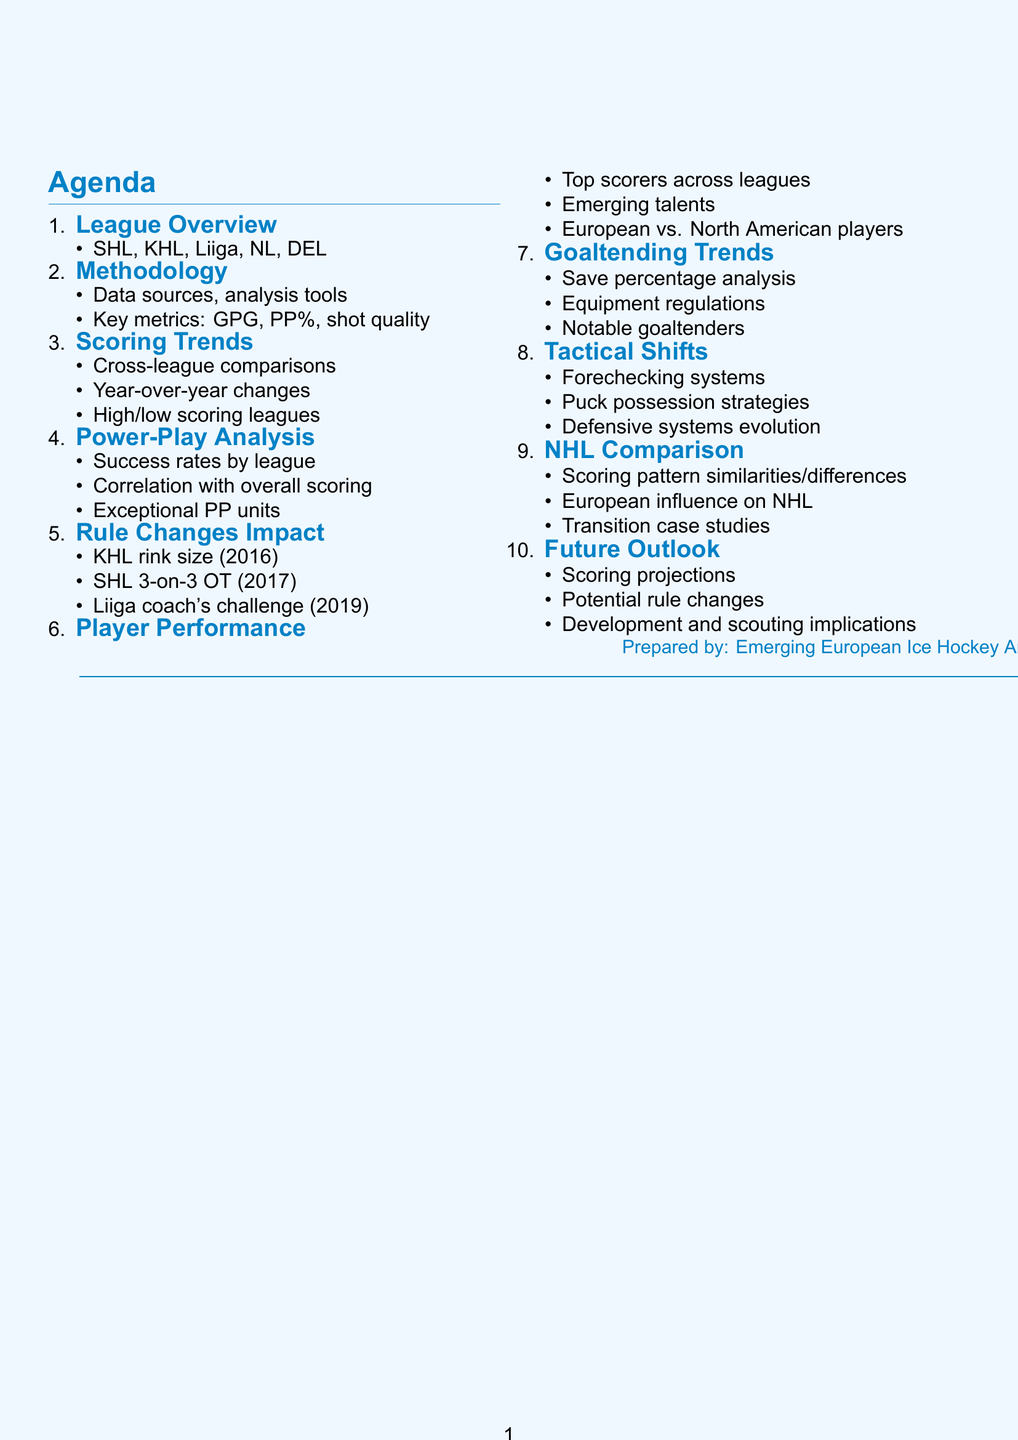What are the top European ice hockey leagues mentioned? The document lists five leagues: SHL, KHL, Liiga, NL, and DEL.
Answer: SHL, KHL, Liiga, NL, DEL What metrics are analyzed in the scoring trends? The metrics include goals per game, power-play efficiency, and shot quality.
Answer: Goals per game, power-play efficiency, shot quality Which league adopted NHL-sized rinks in 2016? The document specifies that the KHL adopted NHL-sized rinks that year.
Answer: KHL Who are two notable young talents mentioned in the player performance analysis? The document highlights Moritz Seider and Tim Stützle as emerging players.
Answer: Moritz Seider, Tim Stützle What is the focus of the tactical shifts section? This section discusses the evolution and adoption of new strategies in ice hockey.
Answer: Tactical evolution and new strategies Which goaltending trend is observed across leagues? The document analyzes save percentage trends among goaltenders in various leagues.
Answer: Save percentage trends What year was the SHL's 3-on-3 overtime rule implemented? According to the document, the SHL introduced this rule in 2017.
Answer: 2017 Name one team with an exceptional power-play unit. The document cites Frölunda HC as an example of a team with a strong power-play.
Answer: Frölunda HC What comparison is made with NHL scoring trends? The document explores similarities and differences in scoring patterns between Europe and the NHL.
Answer: Similarities and differences in scoring patterns What is predicted for future scoring trends in the document? The document suggests potential future scoring trends and implications for player development.
Answer: Future scoring projections and implications 